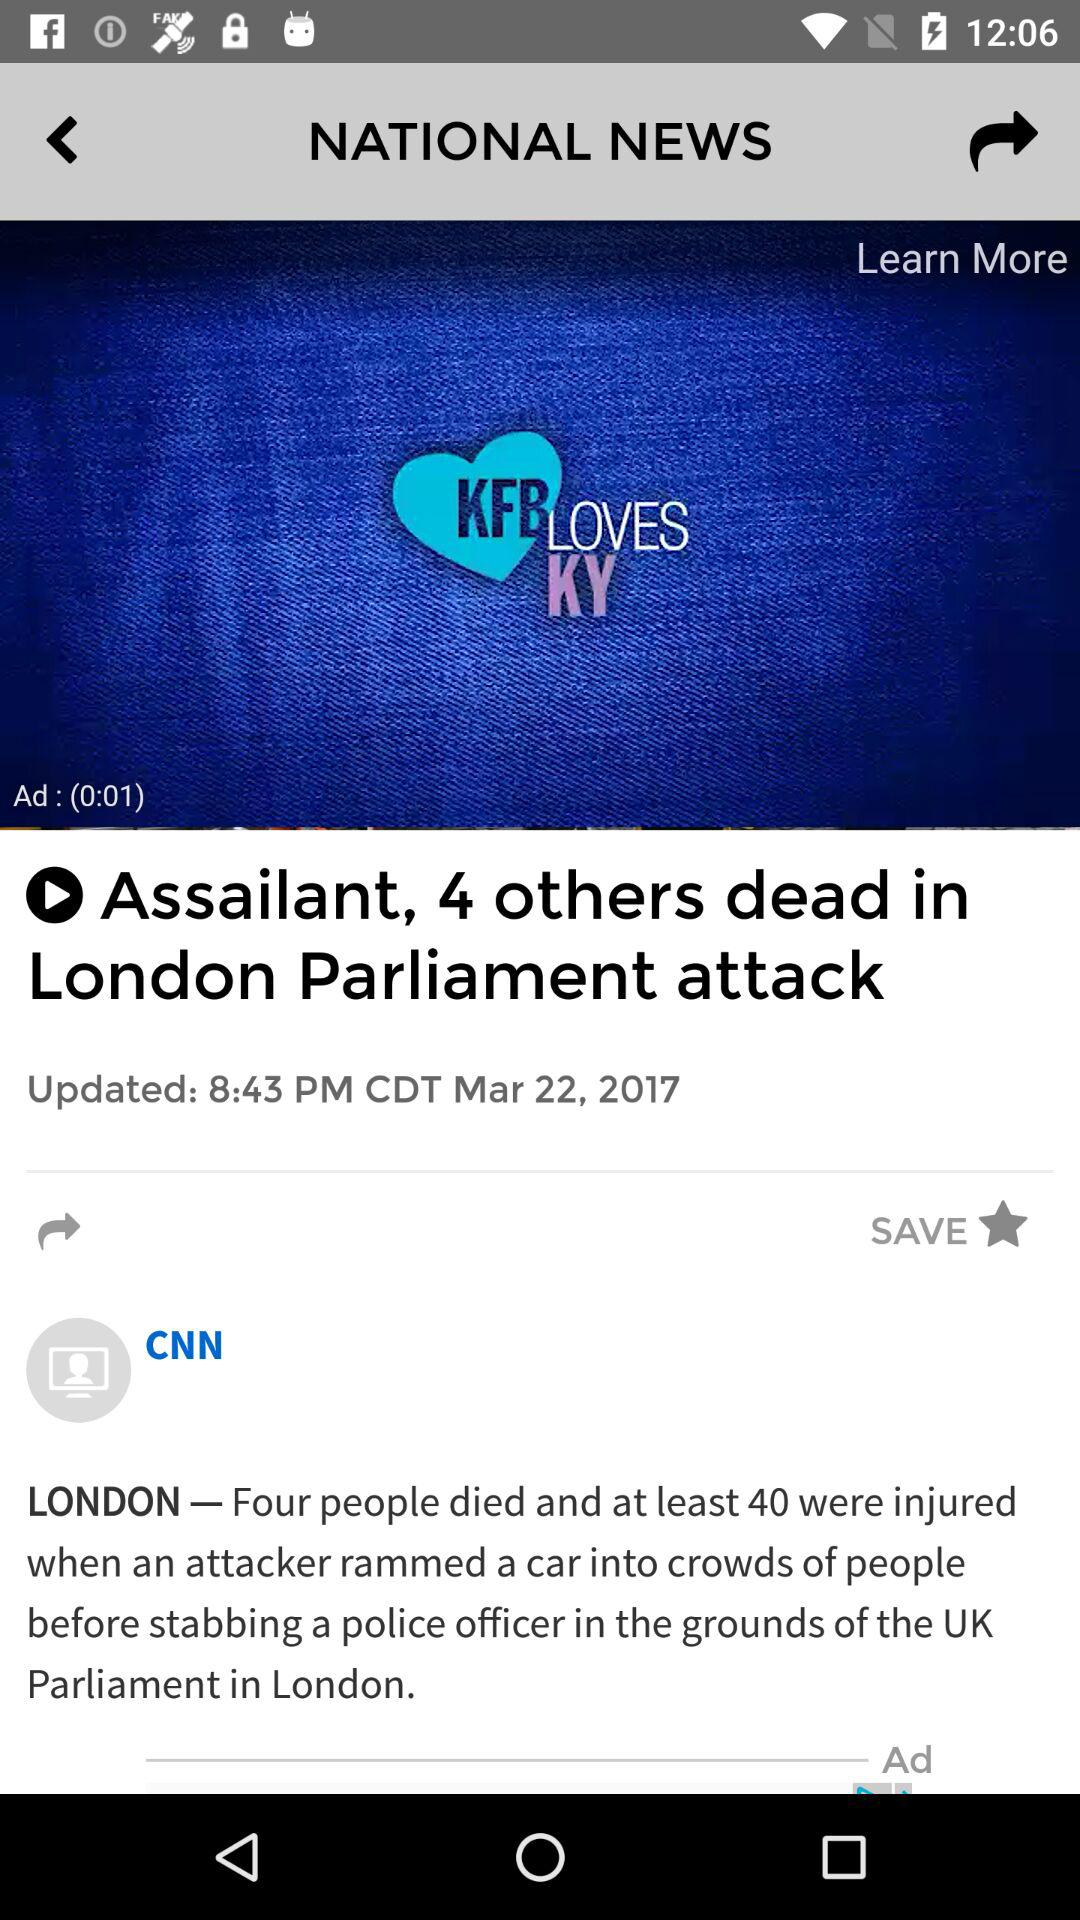How many more people were injured than died in the London Parliament attack?
Answer the question using a single word or phrase. 36 